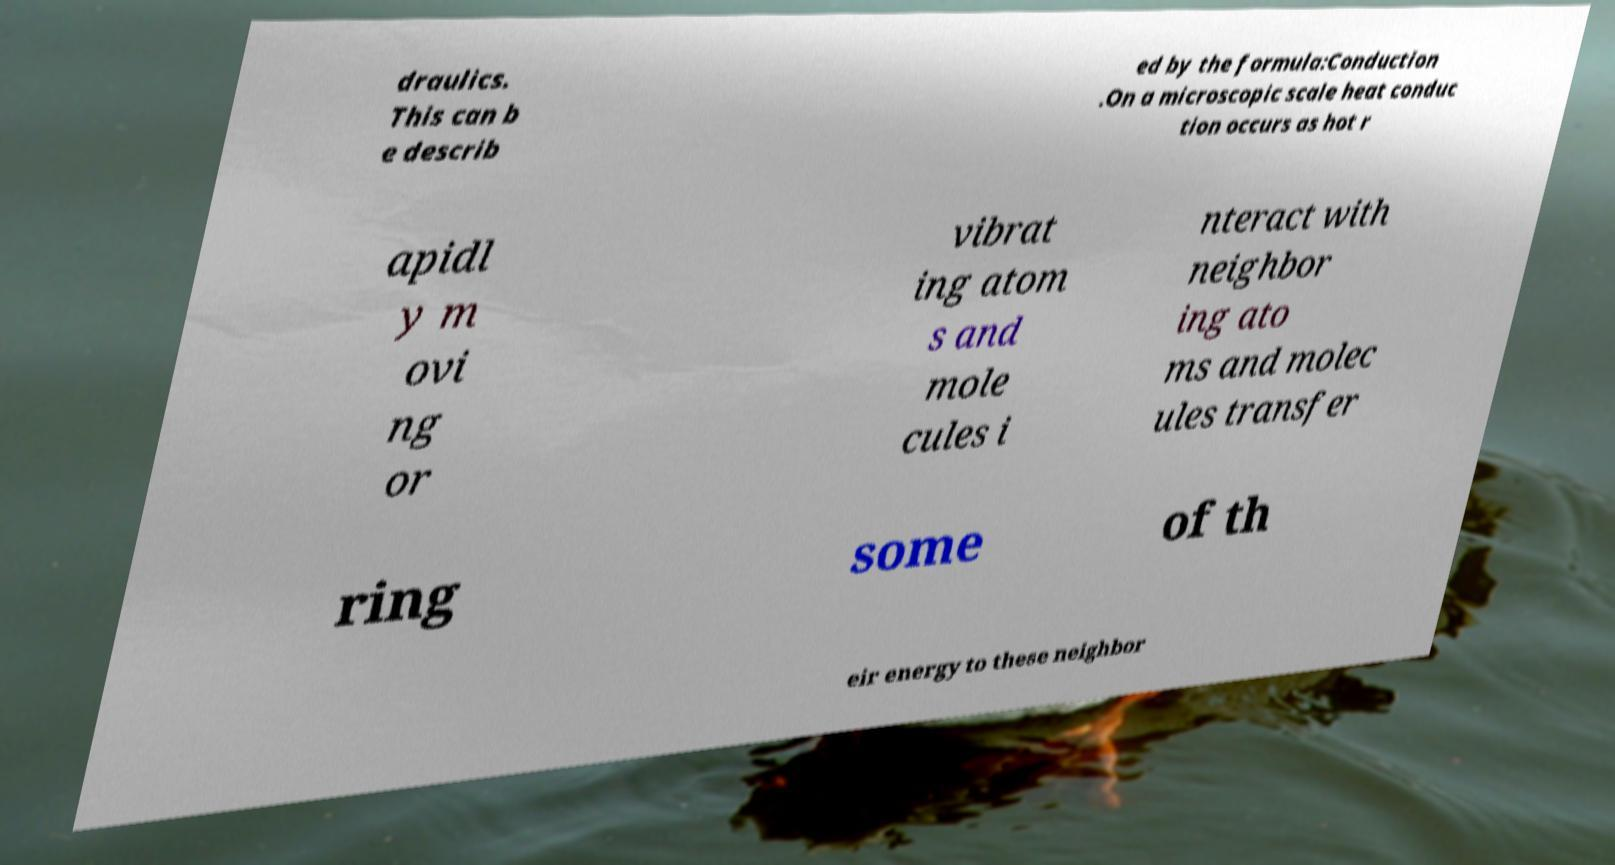Can you accurately transcribe the text from the provided image for me? draulics. This can b e describ ed by the formula:Conduction .On a microscopic scale heat conduc tion occurs as hot r apidl y m ovi ng or vibrat ing atom s and mole cules i nteract with neighbor ing ato ms and molec ules transfer ring some of th eir energy to these neighbor 